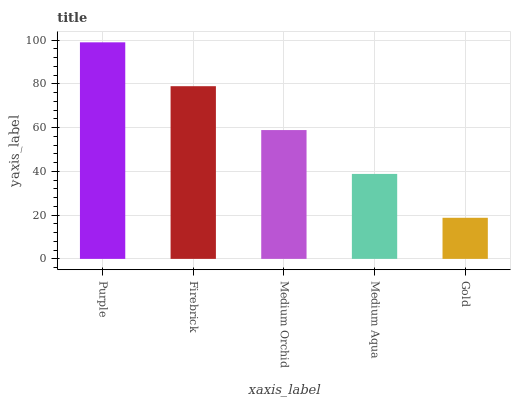Is Gold the minimum?
Answer yes or no. Yes. Is Purple the maximum?
Answer yes or no. Yes. Is Firebrick the minimum?
Answer yes or no. No. Is Firebrick the maximum?
Answer yes or no. No. Is Purple greater than Firebrick?
Answer yes or no. Yes. Is Firebrick less than Purple?
Answer yes or no. Yes. Is Firebrick greater than Purple?
Answer yes or no. No. Is Purple less than Firebrick?
Answer yes or no. No. Is Medium Orchid the high median?
Answer yes or no. Yes. Is Medium Orchid the low median?
Answer yes or no. Yes. Is Firebrick the high median?
Answer yes or no. No. Is Gold the low median?
Answer yes or no. No. 